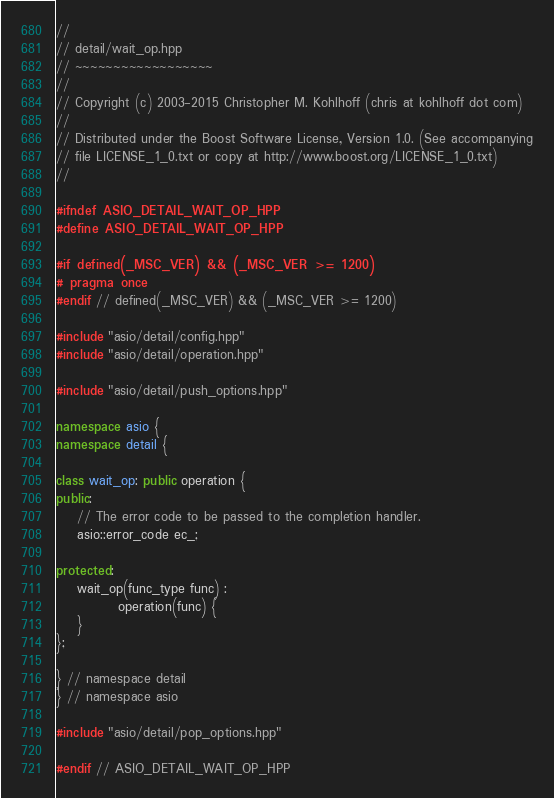<code> <loc_0><loc_0><loc_500><loc_500><_C++_>//
// detail/wait_op.hpp
// ~~~~~~~~~~~~~~~~~~
//
// Copyright (c) 2003-2015 Christopher M. Kohlhoff (chris at kohlhoff dot com)
//
// Distributed under the Boost Software License, Version 1.0. (See accompanying
// file LICENSE_1_0.txt or copy at http://www.boost.org/LICENSE_1_0.txt)
//

#ifndef ASIO_DETAIL_WAIT_OP_HPP
#define ASIO_DETAIL_WAIT_OP_HPP

#if defined(_MSC_VER) && (_MSC_VER >= 1200)
# pragma once
#endif // defined(_MSC_VER) && (_MSC_VER >= 1200)

#include "asio/detail/config.hpp"
#include "asio/detail/operation.hpp"

#include "asio/detail/push_options.hpp"

namespace asio {
namespace detail {

class wait_op: public operation {
public:
	// The error code to be passed to the completion handler.
	asio::error_code ec_;

protected:
	wait_op(func_type func) :
			operation(func) {
	}
};

} // namespace detail
} // namespace asio

#include "asio/detail/pop_options.hpp"

#endif // ASIO_DETAIL_WAIT_OP_HPP
</code> 